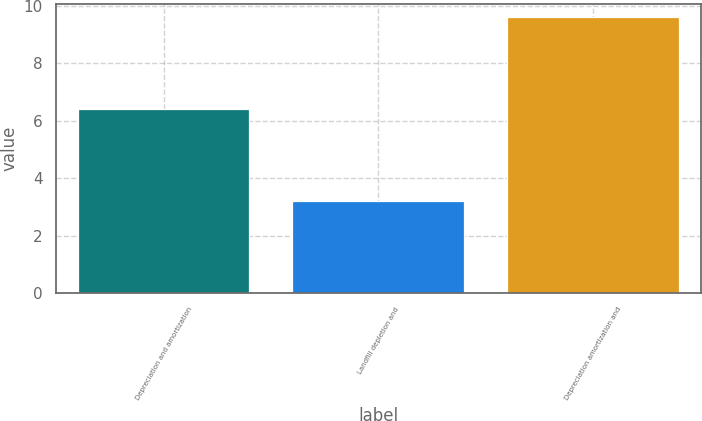<chart> <loc_0><loc_0><loc_500><loc_500><bar_chart><fcel>Depreciation and amortization<fcel>Landfill depletion and<fcel>Depreciation amortization and<nl><fcel>6.4<fcel>3.2<fcel>9.6<nl></chart> 